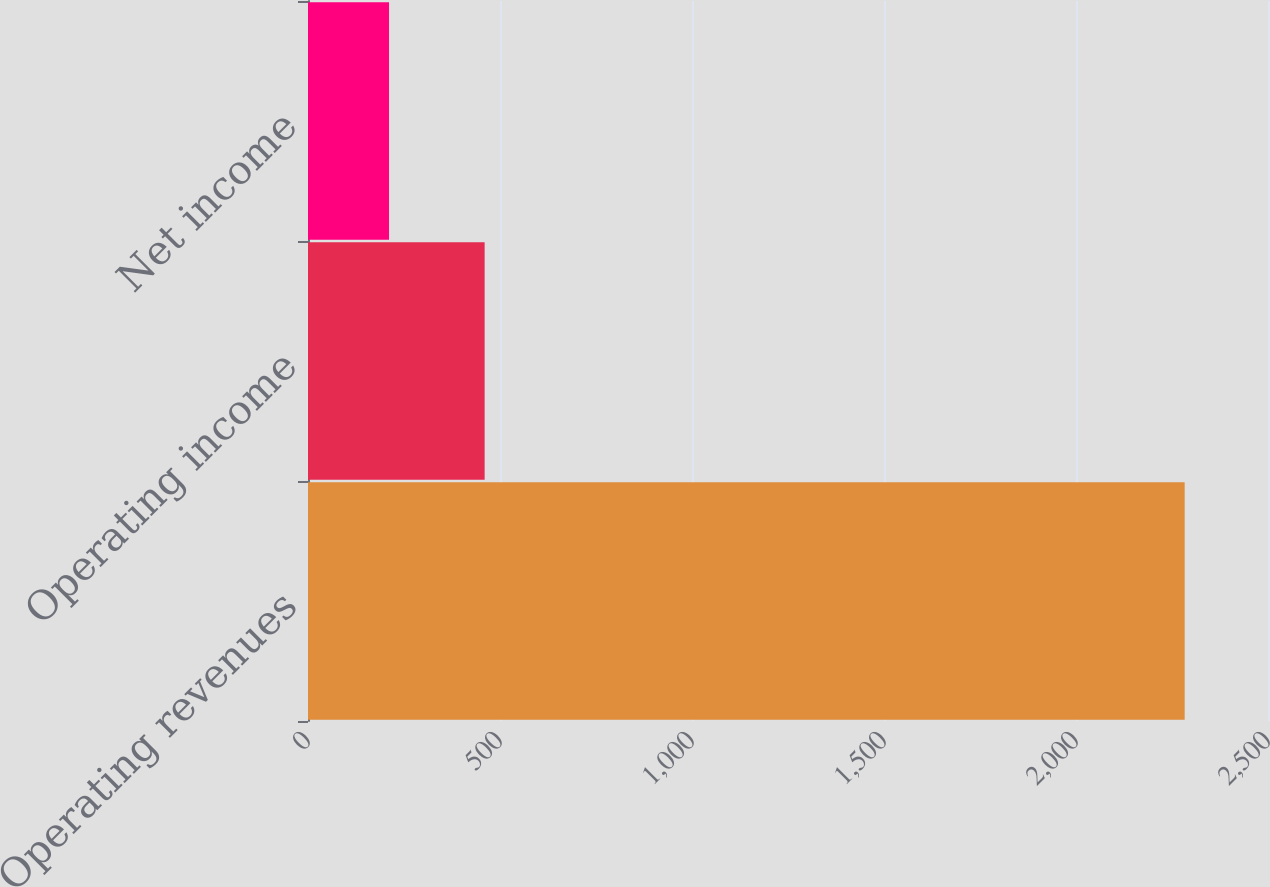<chart> <loc_0><loc_0><loc_500><loc_500><bar_chart><fcel>Operating revenues<fcel>Operating income<fcel>Net income<nl><fcel>2283<fcel>460<fcel>211<nl></chart> 